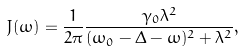<formula> <loc_0><loc_0><loc_500><loc_500>J ( \omega ) = \frac { 1 } { 2 \pi } \frac { \gamma _ { 0 } \lambda ^ { 2 } } { ( \omega _ { 0 } - \Delta - \omega ) ^ { 2 } + \lambda ^ { 2 } } ,</formula> 